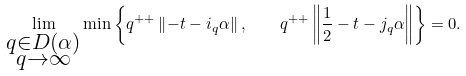Convert formula to latex. <formula><loc_0><loc_0><loc_500><loc_500>\lim _ { \substack { q \in D ( \alpha ) \\ q \rightarrow \infty } } \min \left \{ q ^ { + + } \left \| - t - i _ { q } \alpha \right \| , \quad q ^ { + + } \left \| \frac { 1 } { 2 } - t - j _ { q } \alpha \right \| \right \} = 0 .</formula> 